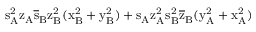Convert formula to latex. <formula><loc_0><loc_0><loc_500><loc_500>s _ { A } ^ { 2 } \mathrm { z _ { A } \mathrm { \overline { s } _ { B } \mathrm { z _ { B } ^ { 2 } ( \mathrm { x _ { B } ^ { 2 } + \mathrm { y _ { B } ^ { 2 } ) + \mathrm { s _ { A } \mathrm { z _ { A } ^ { 2 } \mathrm { s _ { B } ^ { 2 } \mathrm { \overline { z } _ { B } ( \mathrm { y _ { A } ^ { 2 } + \mathrm { x _ { A } ^ { 2 } ) } } } } } } } } } } }</formula> 